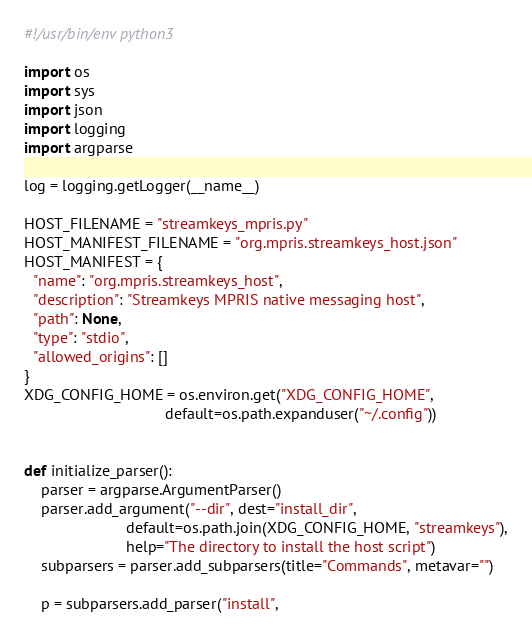<code> <loc_0><loc_0><loc_500><loc_500><_Python_>#!/usr/bin/env python3

import os
import sys
import json
import logging
import argparse

log = logging.getLogger(__name__)

HOST_FILENAME = "streamkeys_mpris.py"
HOST_MANIFEST_FILENAME = "org.mpris.streamkeys_host.json"
HOST_MANIFEST = {
  "name": "org.mpris.streamkeys_host",
  "description": "Streamkeys MPRIS native messaging host",
  "path": None,
  "type": "stdio",
  "allowed_origins": []
}
XDG_CONFIG_HOME = os.environ.get("XDG_CONFIG_HOME",
                                 default=os.path.expanduser("~/.config"))


def initialize_parser():
    parser = argparse.ArgumentParser()
    parser.add_argument("--dir", dest="install_dir",
                        default=os.path.join(XDG_CONFIG_HOME, "streamkeys"),
                        help="The directory to install the host script")
    subparsers = parser.add_subparsers(title="Commands", metavar="")

    p = subparsers.add_parser("install",</code> 